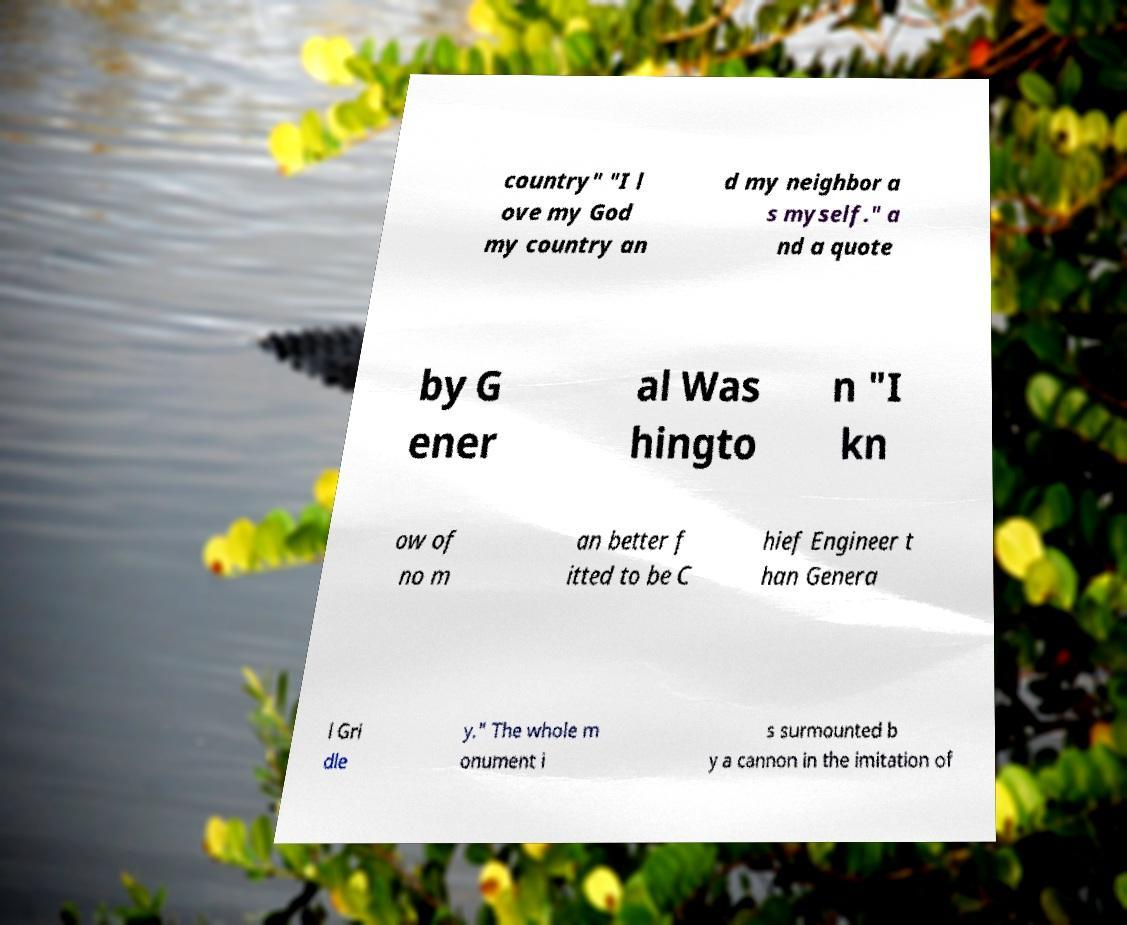Can you accurately transcribe the text from the provided image for me? country" "I l ove my God my country an d my neighbor a s myself." a nd a quote by G ener al Was hingto n "I kn ow of no m an better f itted to be C hief Engineer t han Genera l Gri dle y." The whole m onument i s surmounted b y a cannon in the imitation of 